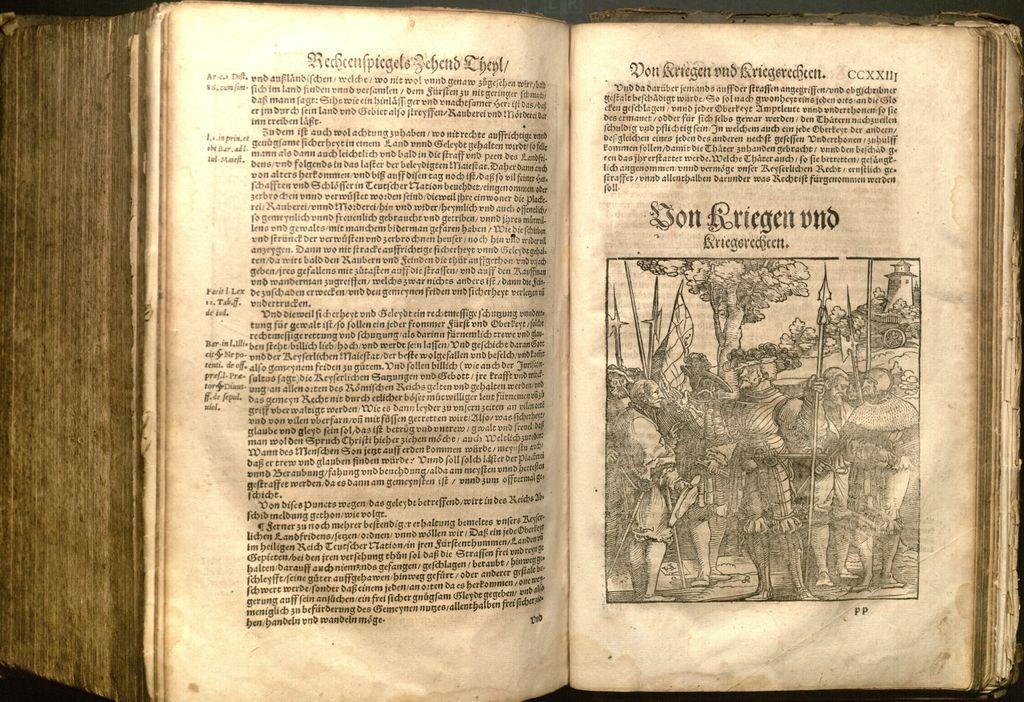How would you summarize this image in a sentence or two? In this picture I can see there is a book here and it has a picture and there are few people standing here and holding weapons and there are plants, trees in the backdrop. 